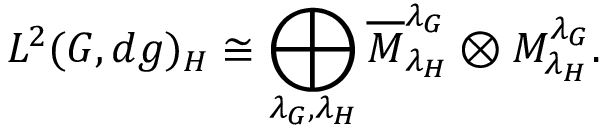Convert formula to latex. <formula><loc_0><loc_0><loc_500><loc_500>L ^ { 2 } ( G , d g ) _ { H } \cong \bigoplus _ { \lambda _ { G } , \lambda _ { H } } \overline { M } _ { \lambda _ { H } } ^ { \lambda _ { G } } \otimes M _ { \lambda _ { H } } ^ { \lambda _ { G } } .</formula> 